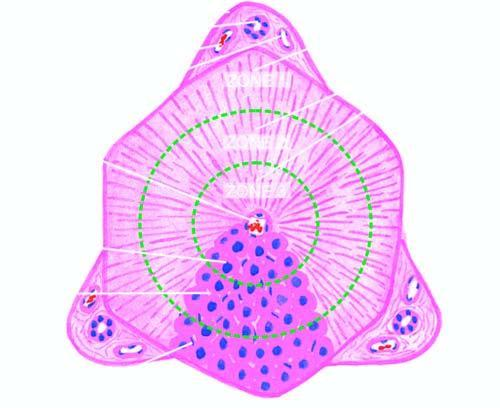re the atypical dysplastic squamous cells shown by circles?
Answer the question using a single word or phrase. No 